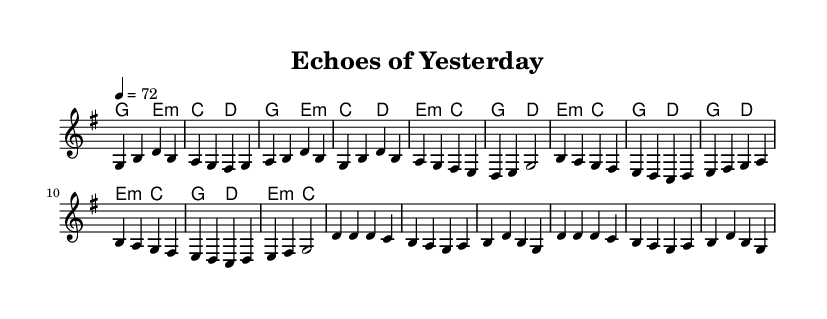What is the key signature of this music? The key signature is G major, which has one sharp (F#). This can be identified at the beginning of the score where the key signature is indicated.
Answer: G major What is the time signature of this music? The time signature is 4/4, which is noted at the beginning of the score. This means there are four beats in each measure and the quarter note gets one beat.
Answer: 4/4 What is the tempo marking for this piece? The tempo marking is 4 = 72, which indicates that there should be 72 quarter note beats per minute. This information is also found at the beginning of the score, under the tempo directive.
Answer: 72 How many measures are in the chorus section? The chorus section contains four measures, as counted by visually separating the measures in that part of the score. Each part is separated by vertical lines in the sheet music.
Answer: 4 What is the first note of the pre-chorus? The first note of the pre-chorus is B, which is found at the beginning of the pre-chorus section in the melody line.
Answer: B What is the harmonic progression used in the verse? The harmonic progression in the verse follows: G, E minor, C, D, repeated throughout. This can be deduced by looking at the chord names aligned with the melody in the verse section.
Answer: G, E minor, C, D What type of vocal performance is typical for this piece? The typical vocal performance is characterized by powerful, emotive singing, which is a hallmark of contemporary pop ballads. This is inferred from the context and known characteristics of the genre based on the structure and melodic content of the piece.
Answer: Powerful vocal performance 